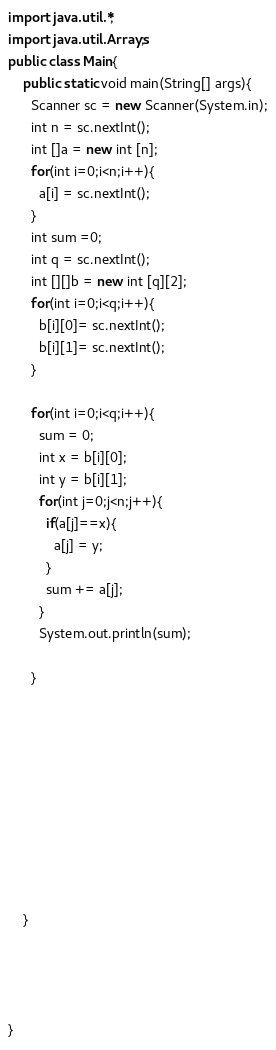Convert code to text. <code><loc_0><loc_0><loc_500><loc_500><_Java_>import java.util.*;
import java.util.Arrays;
public class Main{
    public static void main(String[] args){
      Scanner sc = new Scanner(System.in);
      int n = sc.nextInt();
      int []a = new int [n];
      for(int i=0;i<n;i++){
        a[i] = sc.nextInt();
      }
      int sum =0;
      int q = sc.nextInt();
      int [][]b = new int [q][2];
      for(int i=0;i<q;i++){
        b[i][0]= sc.nextInt();
        b[i][1]= sc.nextInt();
      }
      
      for(int i=0;i<q;i++){
        sum = 0;
        int x = b[i][0];
        int y = b[i][1];
        for(int j=0;j<n;j++){
          if(a[j]==x){
            a[j] = y;
          }
          sum += a[j];
        }
        System.out.println(sum);
        
      }
      
      



      
      
      

     
    }
   
    
   
    
}</code> 